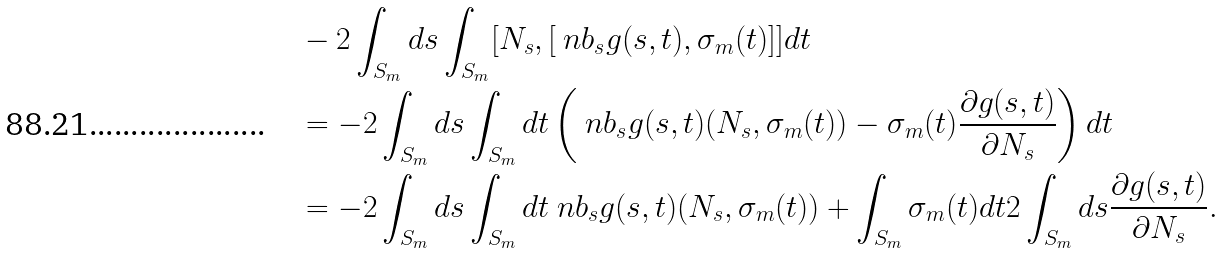<formula> <loc_0><loc_0><loc_500><loc_500>& - 2 \int _ { S _ { m } } d s \int _ { S _ { m } } [ N _ { s } , [ \ n b _ { s } g ( s , t ) , \sigma _ { m } ( t ) ] ] d t \\ & = - 2 \int _ { S _ { m } } d s \int _ { S _ { m } } d t \left ( \ n b _ { s } g ( s , t ) ( N _ { s } , \sigma _ { m } ( t ) ) - \sigma _ { m } ( t ) \frac { \partial g ( s , t ) } { \partial N _ { s } } \right ) d t \\ & = - 2 \int _ { S _ { m } } d s \int _ { S _ { m } } d t \ n b _ { s } g ( s , t ) ( N _ { s } , \sigma _ { m } ( t ) ) + \int _ { S _ { m } } \sigma _ { m } ( t ) d t 2 \int _ { S _ { m } } d s \frac { \partial g ( s , t ) } { \partial N _ { s } } .</formula> 